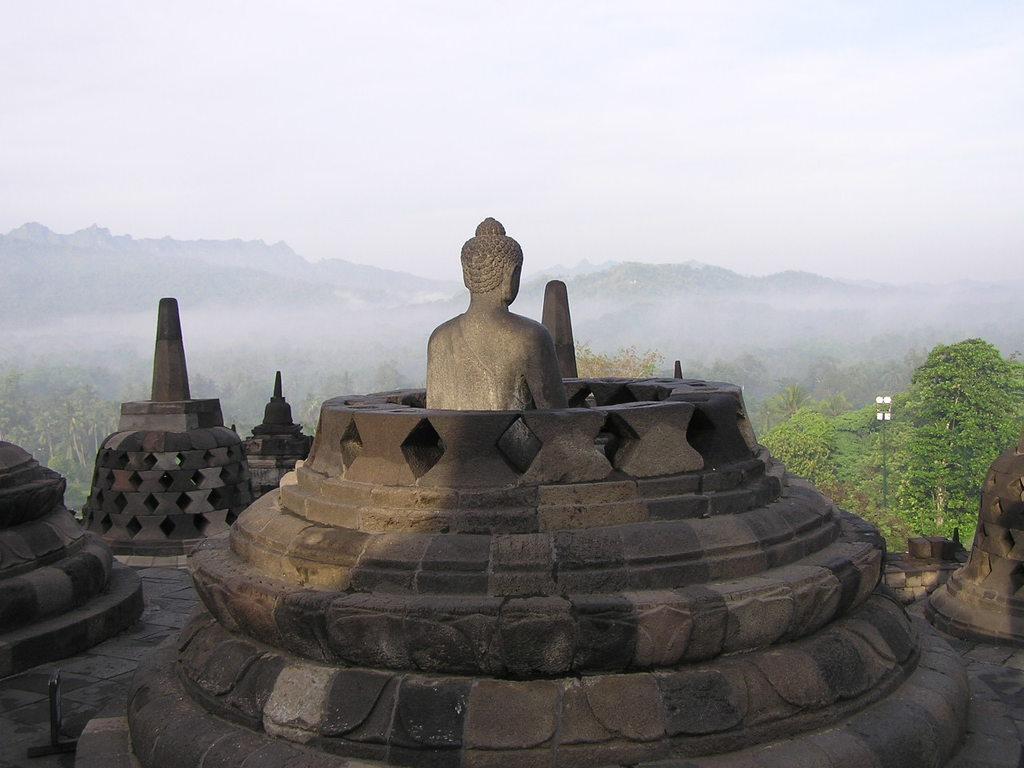Please provide a concise description of this image. In this image, I can see the statue of Lord Buddha sitting. I think this is a temple. These are the trees. In the background, I can see the mountains, which are partially covered by the fog. This is the sky. 